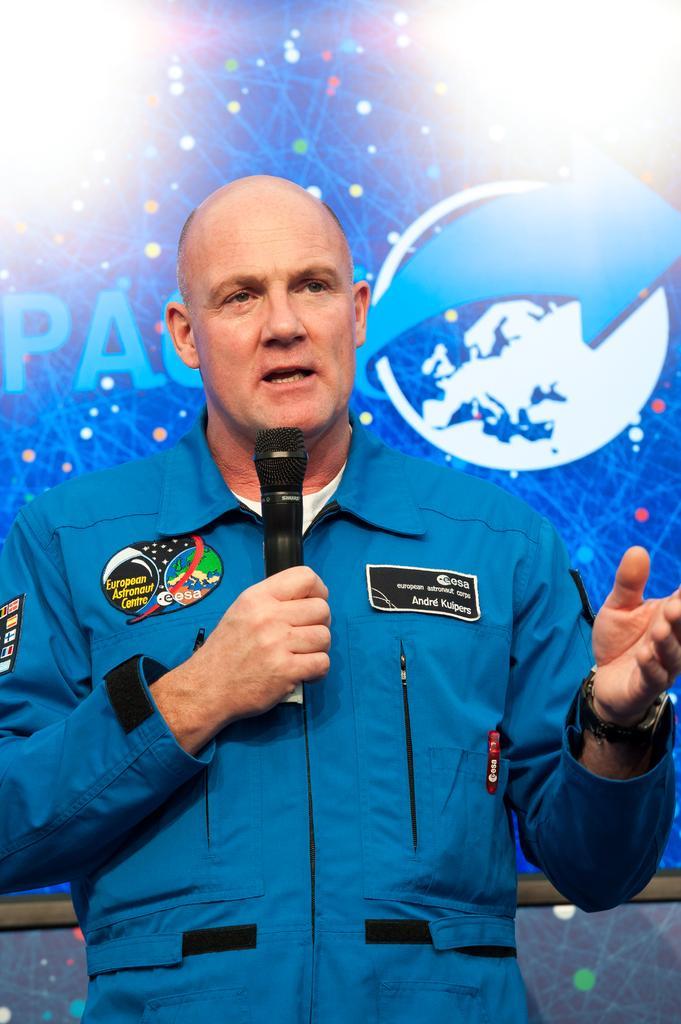How would you summarize this image in a sentence or two? In this picture, we see the man in the uniform is standing. He is holding a microphone in his hand and he is talking on the microphone. Behind him, we see a banner or a board in blue color with some text written on it. 